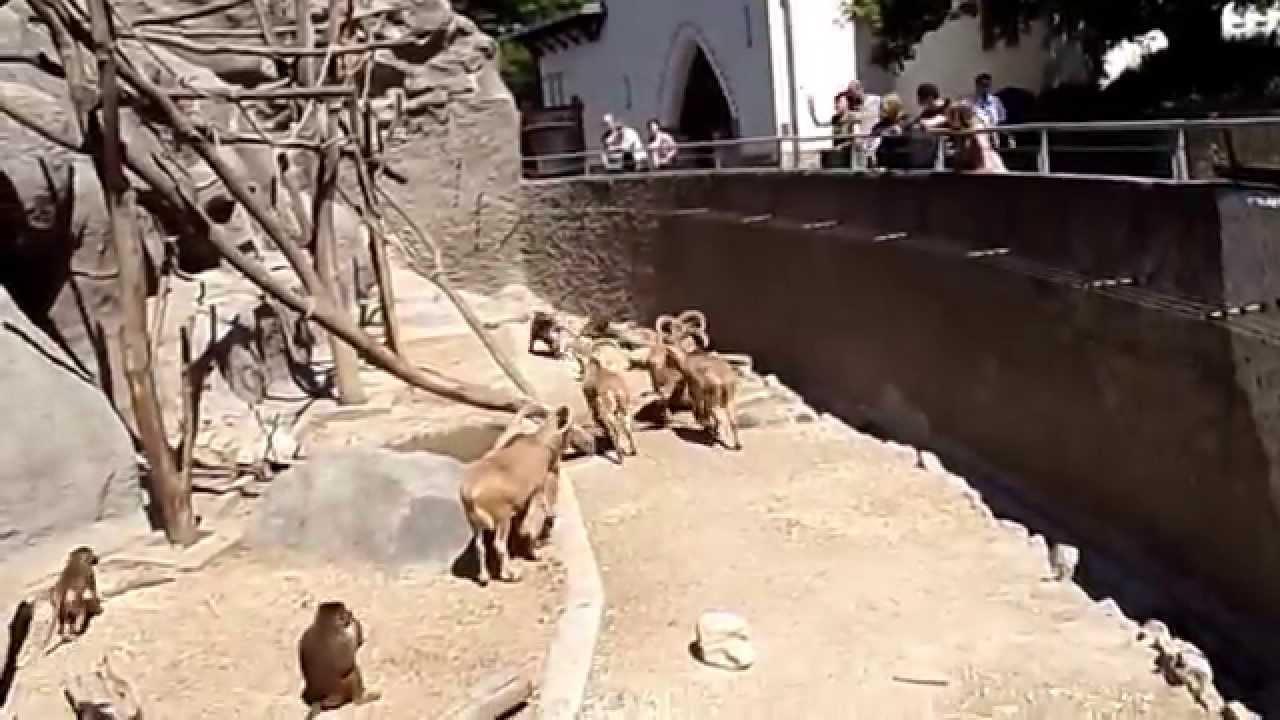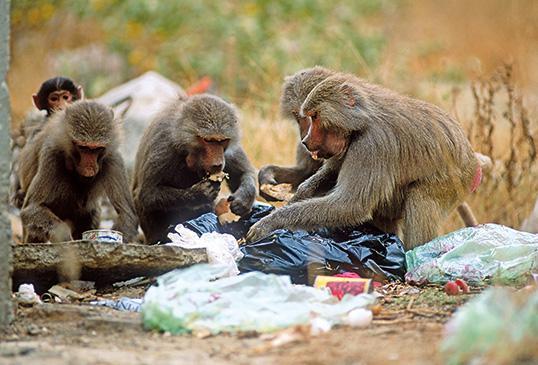The first image is the image on the left, the second image is the image on the right. For the images shown, is this caption "In the image to the right, there are less than six animals." true? Answer yes or no. Yes. 